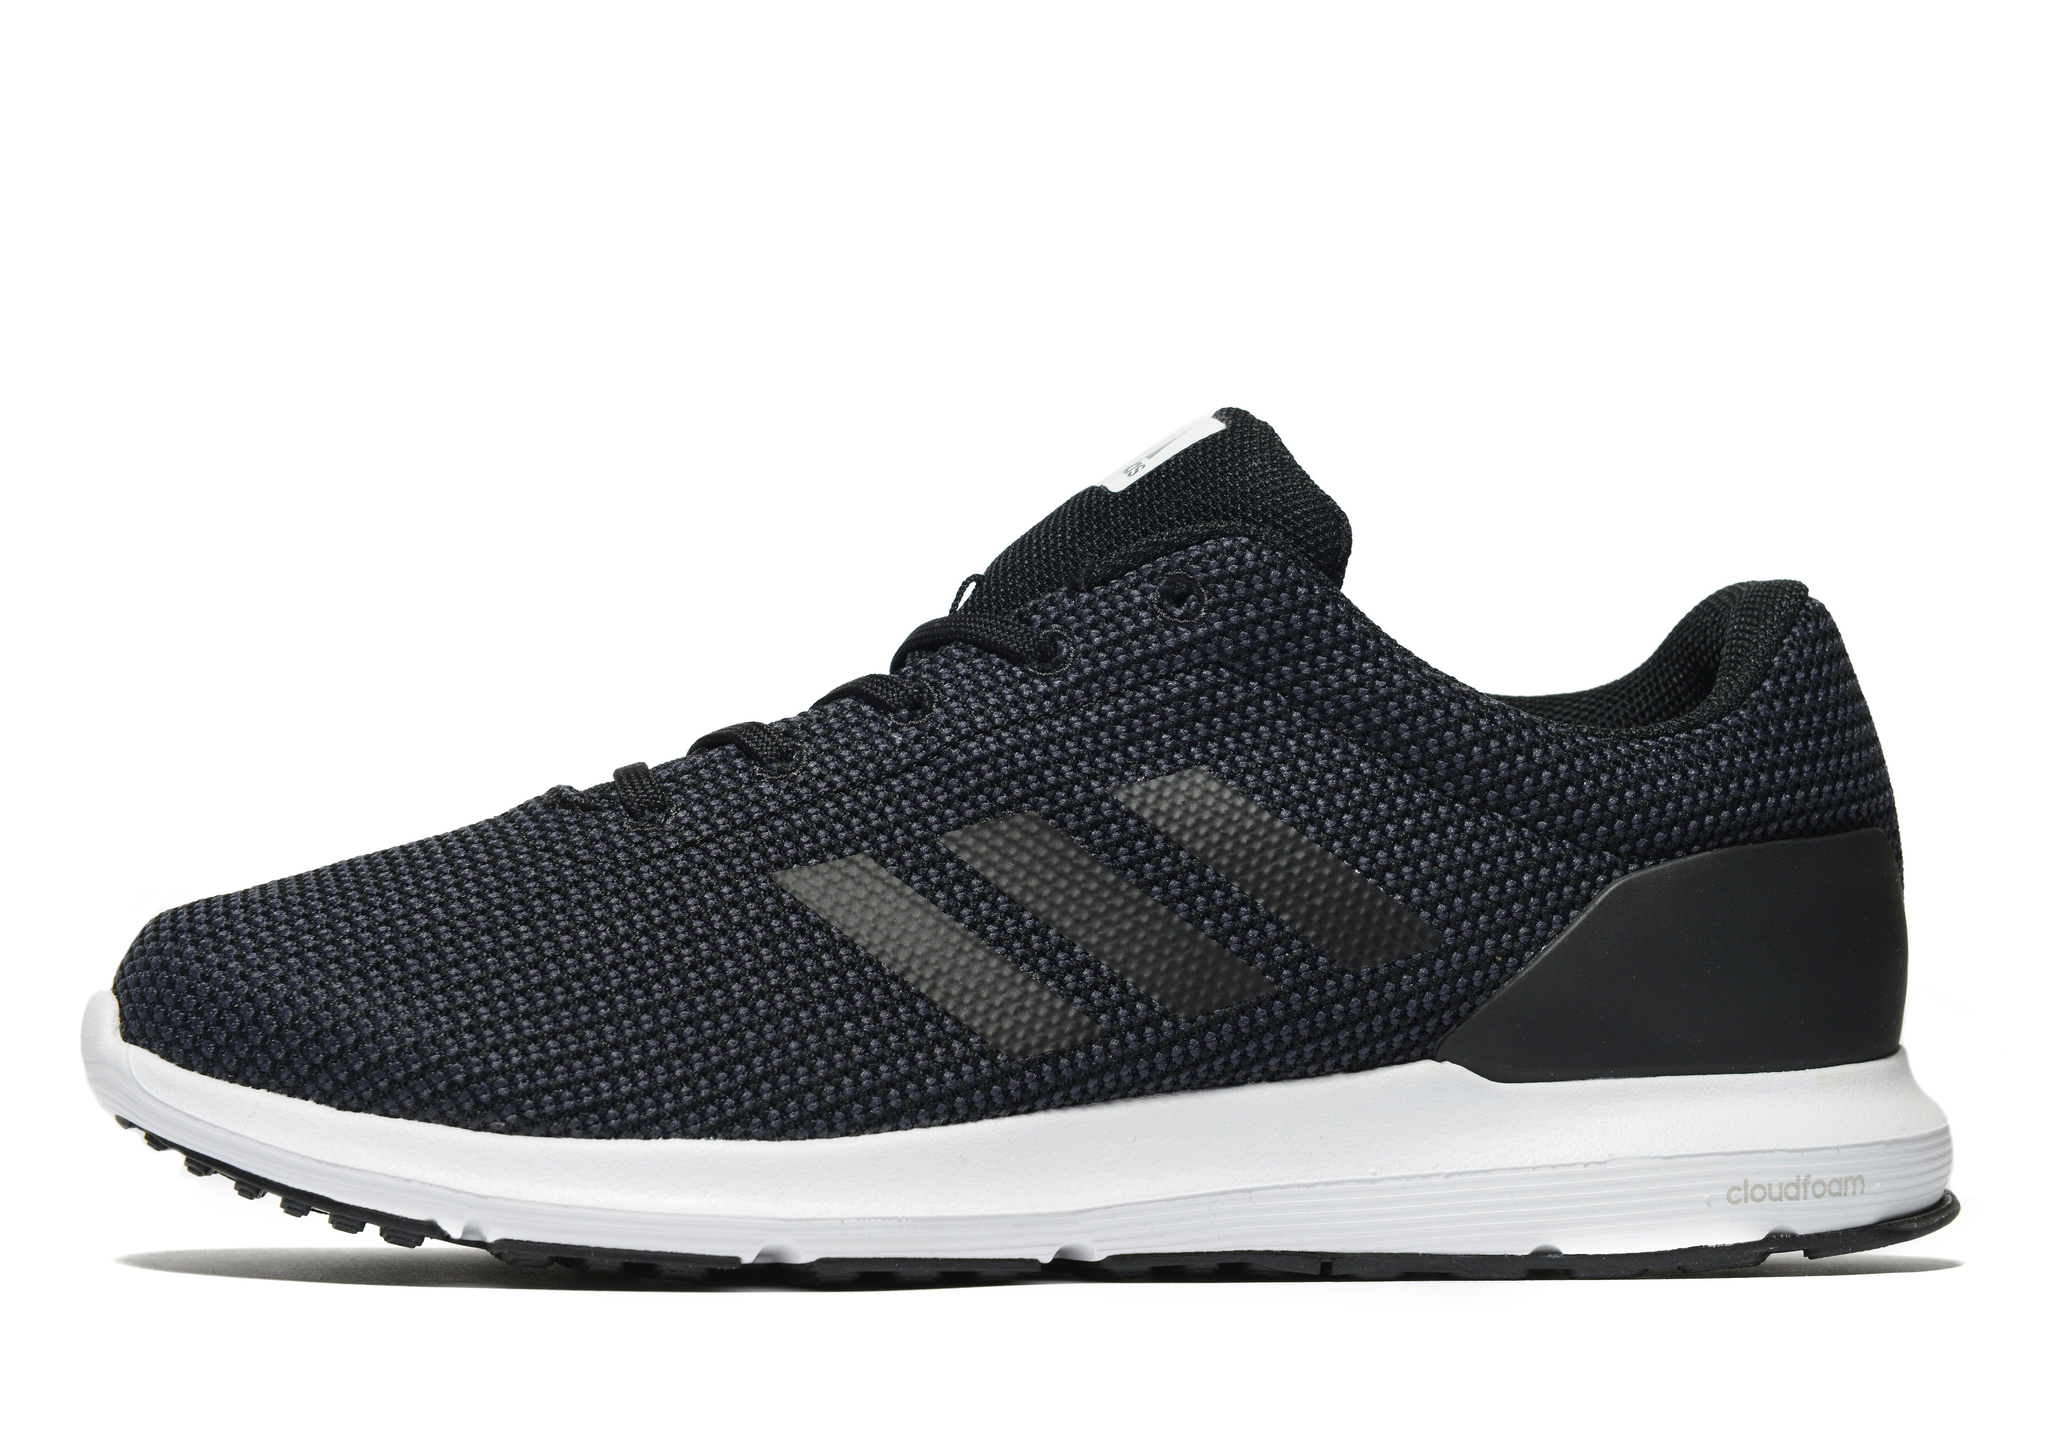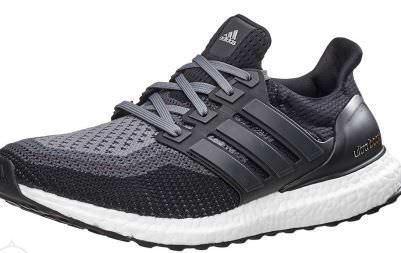The first image is the image on the left, the second image is the image on the right. Considering the images on both sides, is "At least one image has more than one sneaker in it." valid? Answer yes or no. No. 